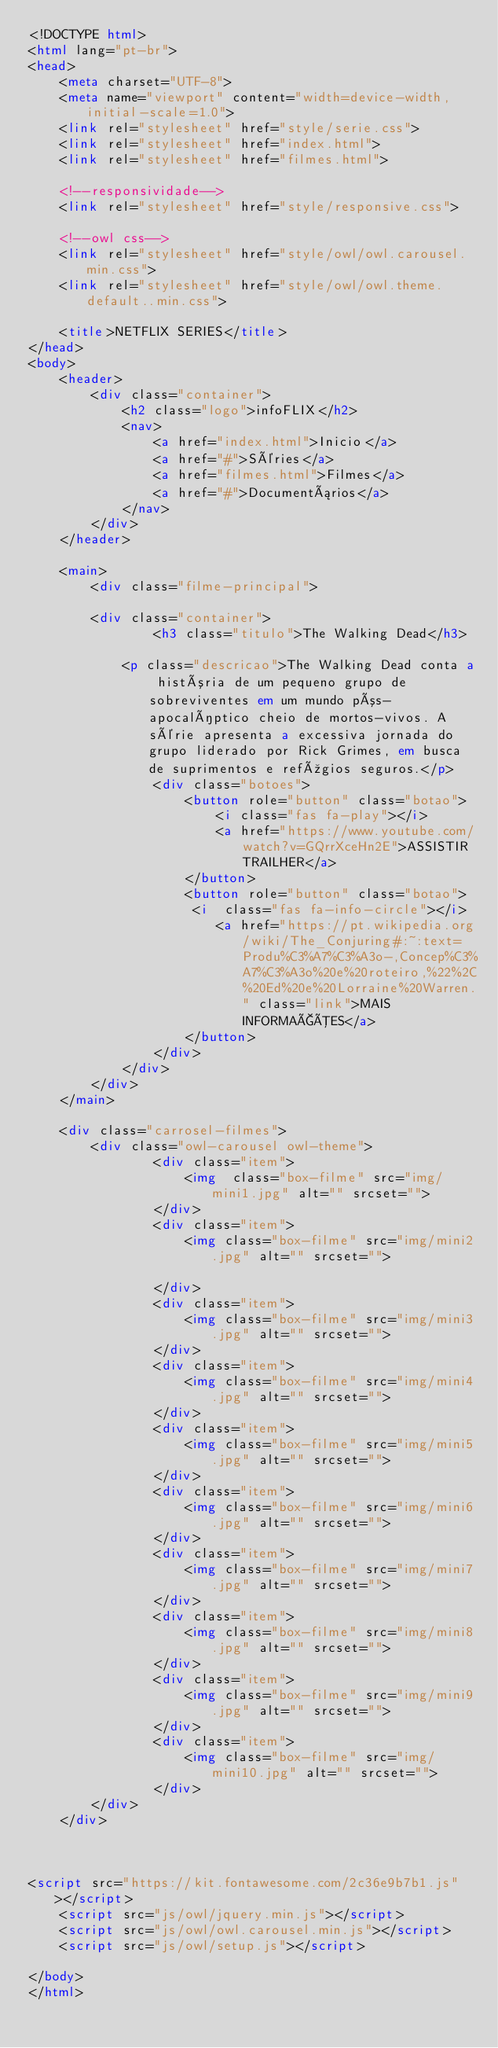Convert code to text. <code><loc_0><loc_0><loc_500><loc_500><_HTML_><!DOCTYPE html>
<html lang="pt-br">
<head>
    <meta charset="UTF-8">
    <meta name="viewport" content="width=device-width, initial-scale=1.0">
    <link rel="stylesheet" href="style/serie.css">
    <link rel="stylesheet" href="index.html">
    <link rel="stylesheet" href="filmes.html">
    
    <!--responsividade-->
    <link rel="stylesheet" href="style/responsive.css">

    <!--owl css-->
    <link rel="stylesheet" href="style/owl/owl.carousel.min.css">
    <link rel="stylesheet" href="style/owl/owl.theme.default..min.css">

    <title>NETFLIX SERIES</title>
</head>
<body>
    <header>
        <div class="container">
            <h2 class="logo">infoFLIX</h2>
            <nav>
                <a href="index.html">Inicio</a>
                <a href="#">Séries</a>
                <a href="filmes.html">Filmes</a>
                <a href="#">Documentários</a>
            </nav>
        </div>
    </header>

    <main>
        <div class="filme-principal">
            
        <div class="container">
                <h3 class="titulo">The Walking Dead</h3>
              
            <p class="descricao">The Walking Dead conta a história de um pequeno grupo de sobreviventes em um mundo pós-apocalíptico cheio de mortos-vivos. A série apresenta a excessiva jornada do grupo liderado por Rick Grimes, em busca de suprimentos e refúgios seguros.</p>
                <div class="botoes">
                    <button role="button" class="botao">
                        <i class="fas fa-play"></i>
                        <a href="https://www.youtube.com/watch?v=GQrrXceHn2E">ASSISTIR TRAILHER</a>
                    </button>
                    <button role="button" class="botao">
                     <i  class="fas fa-info-circle"></i>
                        <a href="https://pt.wikipedia.org/wiki/The_Conjuring#:~:text=Produ%C3%A7%C3%A3o-,Concep%C3%A7%C3%A3o%20e%20roteiro,%22%2C%20Ed%20e%20Lorraine%20Warren." class="link">MAIS INFORMAÇÕES</a>
                    </button>
                </div>
            </div>
        </div>
    </main>

    <div class="carrosel-filmes">
        <div class="owl-carousel owl-theme">
                <div class="item">
                    <img  class="box-filme" src="img/mini1.jpg" alt="" srcset=""> 
                </div>
                <div class="item">
                    <img class="box-filme" src="img/mini2.jpg" alt="" srcset="">
                   
                </div>
                <div class="item">
                    <img class="box-filme" src="img/mini3.jpg" alt="" srcset="">
                </div>
                <div class="item">
                    <img class="box-filme" src="img/mini4.jpg" alt="" srcset="">
                </div>
                <div class="item">
                    <img class="box-filme" src="img/mini5.jpg" alt="" srcset="">
                </div>
                <div class="item">
                    <img class="box-filme" src="img/mini6.jpg" alt="" srcset="">
                </div>
                <div class="item">
                    <img class="box-filme" src="img/mini7.jpg" alt="" srcset="">
                </div>
                <div class="item">
                    <img class="box-filme" src="img/mini8.jpg" alt="" srcset="">
                </div>
                <div class="item">
                    <img class="box-filme" src="img/mini9.jpg" alt="" srcset="">
                </div>
                <div class="item">
                    <img class="box-filme" src="img/mini10.jpg" alt="" srcset="">
                </div>
        </div>
    </div>
   
    

<script src="https://kit.fontawesome.com/2c36e9b7b1.js"></script>
    <script src="js/owl/jquery.min.js"></script>
    <script src="js/owl/owl.carousel.min.js"></script>
    <script src="js/owl/setup.js"></script>
 
</body>
</html></code> 